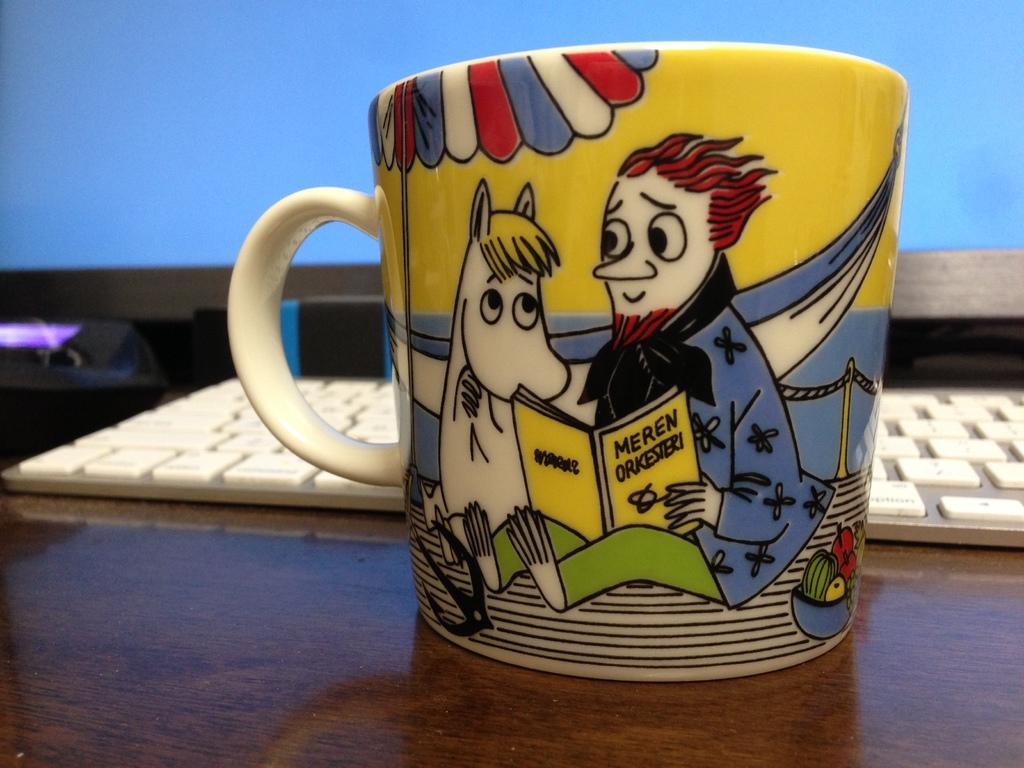<image>
Summarize the visual content of the image. A coffee cup on a wooden surface shows a character reading a book with the word meren on it 